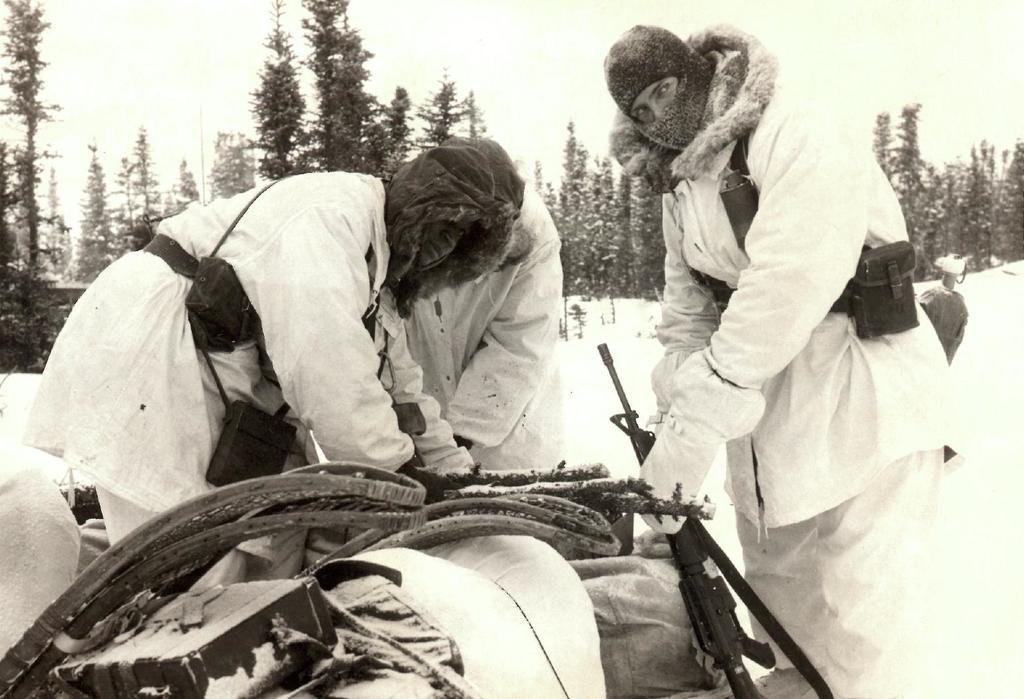What is the position of the man in the image? The man is standing on the right side of the image. What is the man wearing in the image? The man is wearing a white sweater. How many other persons are in the image besides the man? There are two other persons in the image. What can be seen in the background of the image? Trees are visible in the background of the image. What type of approval does the man receive from the sun in the image? There is no sun present in the image, so the man cannot receive any approval from it. Is the man in the image currently in space? There is no indication in the image that the man is in space, so we cannot definitively answer that question. 